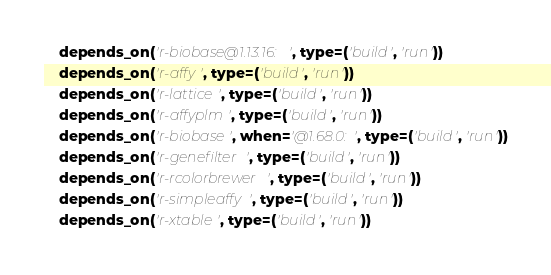<code> <loc_0><loc_0><loc_500><loc_500><_Python_>    depends_on('r-biobase@1.13.16:', type=('build', 'run'))
    depends_on('r-affy', type=('build', 'run'))
    depends_on('r-lattice', type=('build', 'run'))
    depends_on('r-affyplm', type=('build', 'run'))
    depends_on('r-biobase', when='@1.68.0:', type=('build', 'run'))
    depends_on('r-genefilter', type=('build', 'run'))
    depends_on('r-rcolorbrewer', type=('build', 'run'))
    depends_on('r-simpleaffy', type=('build', 'run'))
    depends_on('r-xtable', type=('build', 'run'))
</code> 